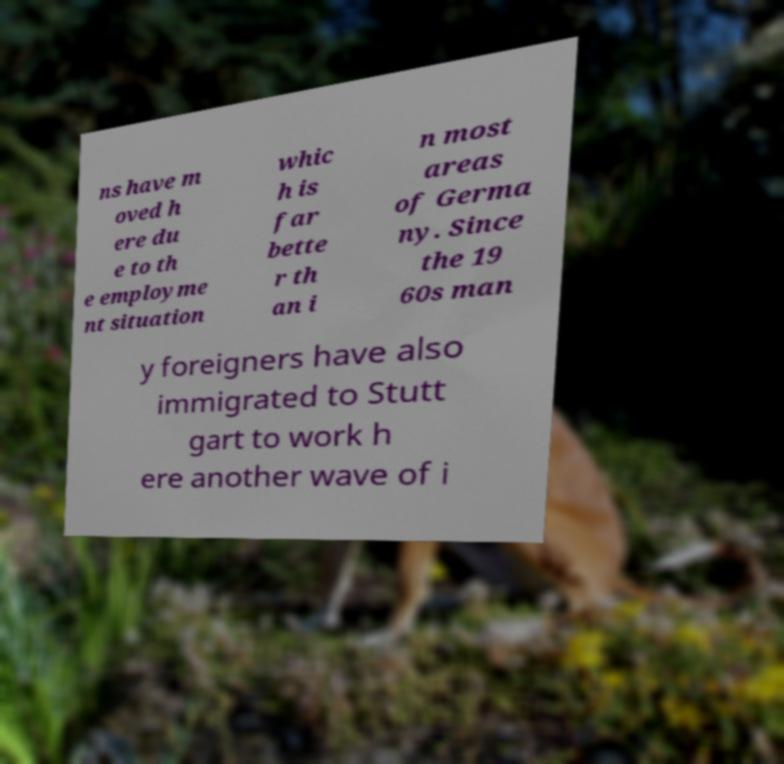For documentation purposes, I need the text within this image transcribed. Could you provide that? ns have m oved h ere du e to th e employme nt situation whic h is far bette r th an i n most areas of Germa ny. Since the 19 60s man y foreigners have also immigrated to Stutt gart to work h ere another wave of i 